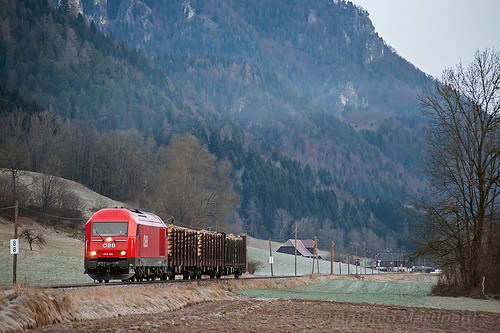<image>
Is there a train in front of the mountain? Yes. The train is positioned in front of the mountain, appearing closer to the camera viewpoint. 